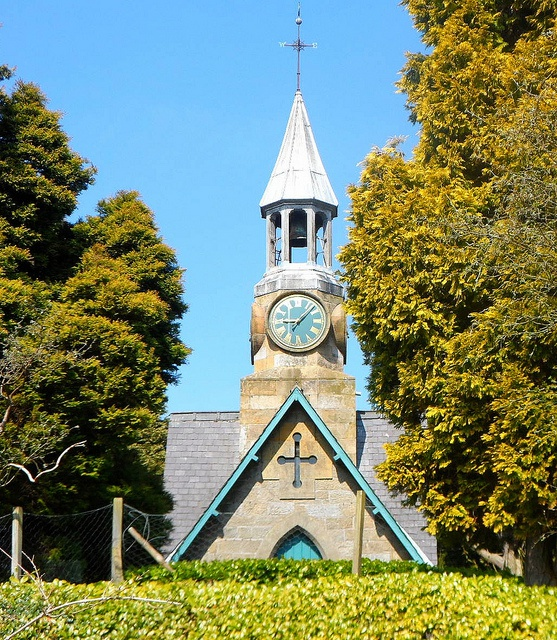Describe the objects in this image and their specific colors. I can see a clock in lightblue, ivory, darkgray, and beige tones in this image. 